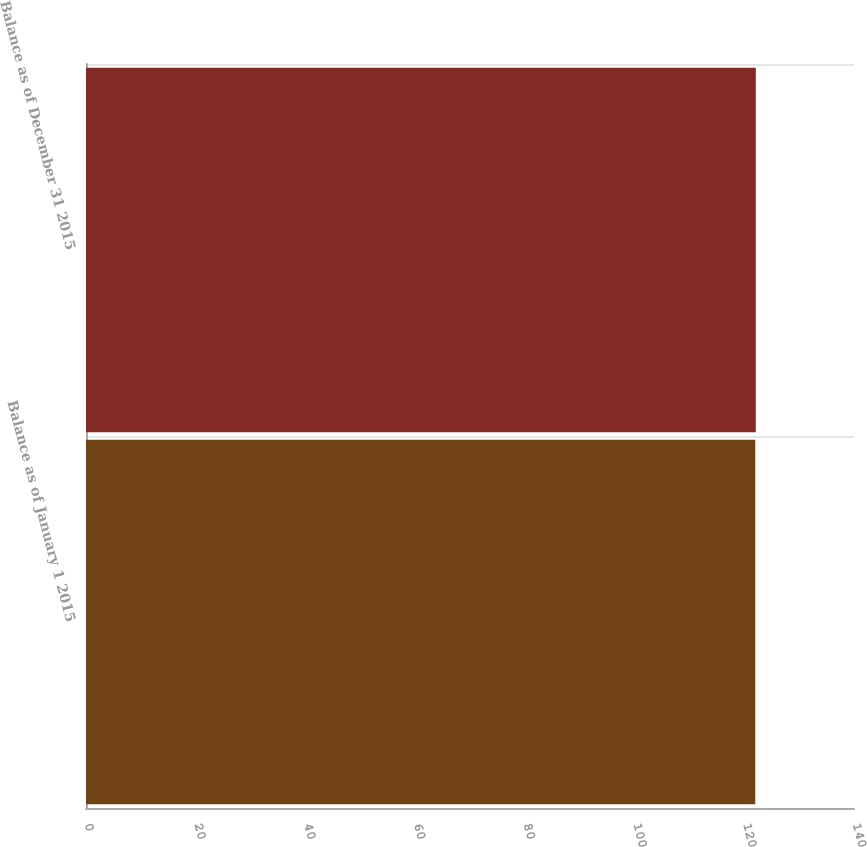Convert chart to OTSL. <chart><loc_0><loc_0><loc_500><loc_500><bar_chart><fcel>Balance as of January 1 2015<fcel>Balance as of December 31 2015<nl><fcel>122<fcel>122.1<nl></chart> 